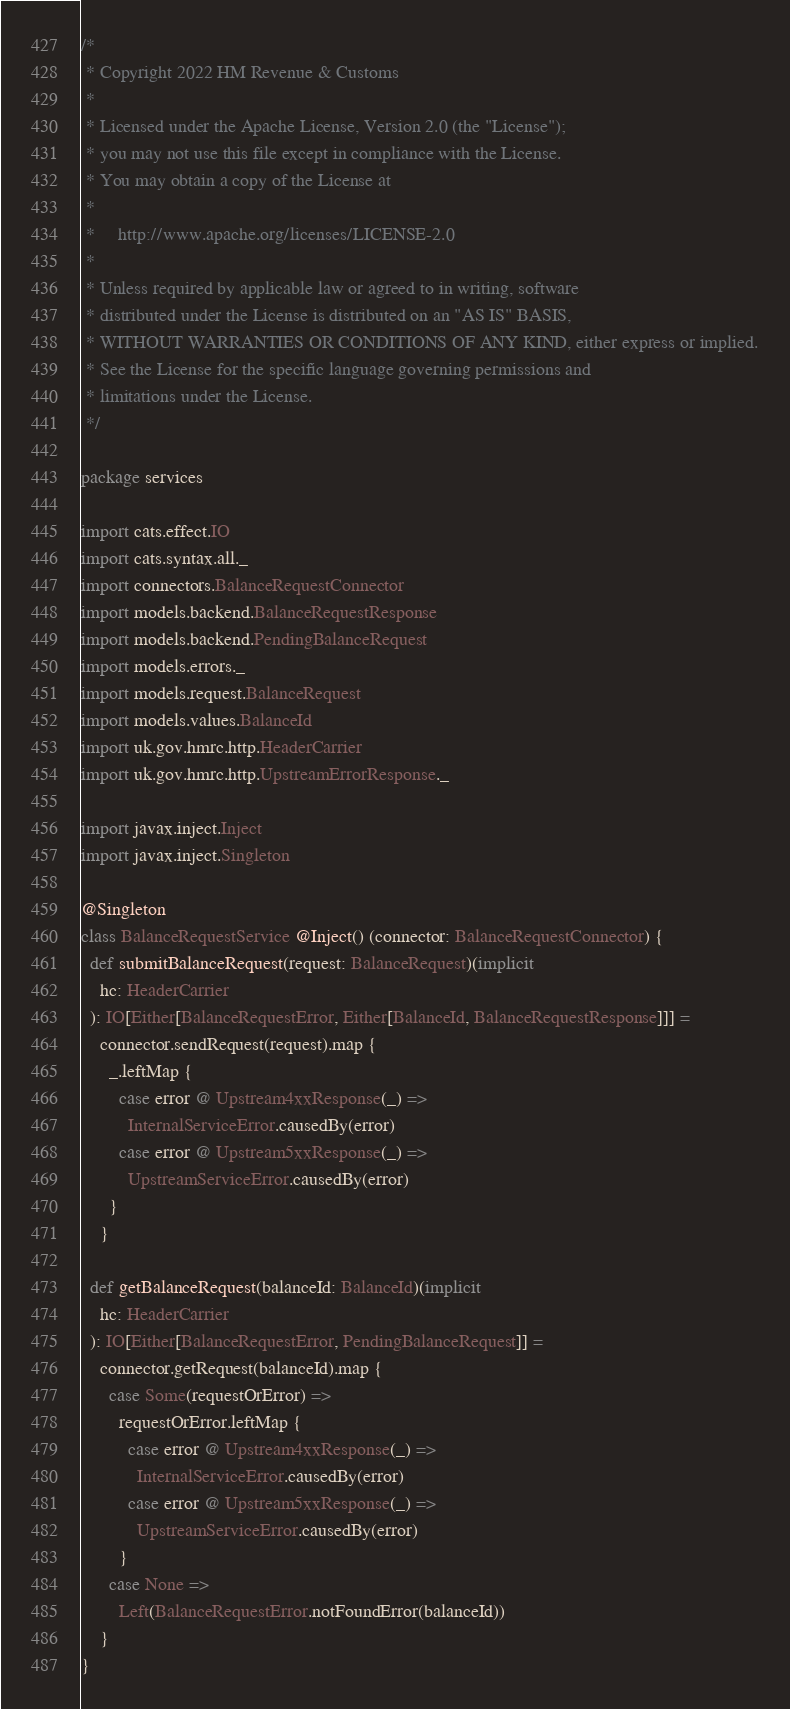Convert code to text. <code><loc_0><loc_0><loc_500><loc_500><_Scala_>/*
 * Copyright 2022 HM Revenue & Customs
 *
 * Licensed under the Apache License, Version 2.0 (the "License");
 * you may not use this file except in compliance with the License.
 * You may obtain a copy of the License at
 *
 *     http://www.apache.org/licenses/LICENSE-2.0
 *
 * Unless required by applicable law or agreed to in writing, software
 * distributed under the License is distributed on an "AS IS" BASIS,
 * WITHOUT WARRANTIES OR CONDITIONS OF ANY KIND, either express or implied.
 * See the License for the specific language governing permissions and
 * limitations under the License.
 */

package services

import cats.effect.IO
import cats.syntax.all._
import connectors.BalanceRequestConnector
import models.backend.BalanceRequestResponse
import models.backend.PendingBalanceRequest
import models.errors._
import models.request.BalanceRequest
import models.values.BalanceId
import uk.gov.hmrc.http.HeaderCarrier
import uk.gov.hmrc.http.UpstreamErrorResponse._

import javax.inject.Inject
import javax.inject.Singleton

@Singleton
class BalanceRequestService @Inject() (connector: BalanceRequestConnector) {
  def submitBalanceRequest(request: BalanceRequest)(implicit
    hc: HeaderCarrier
  ): IO[Either[BalanceRequestError, Either[BalanceId, BalanceRequestResponse]]] =
    connector.sendRequest(request).map {
      _.leftMap {
        case error @ Upstream4xxResponse(_) =>
          InternalServiceError.causedBy(error)
        case error @ Upstream5xxResponse(_) =>
          UpstreamServiceError.causedBy(error)
      }
    }

  def getBalanceRequest(balanceId: BalanceId)(implicit
    hc: HeaderCarrier
  ): IO[Either[BalanceRequestError, PendingBalanceRequest]] =
    connector.getRequest(balanceId).map {
      case Some(requestOrError) =>
        requestOrError.leftMap {
          case error @ Upstream4xxResponse(_) =>
            InternalServiceError.causedBy(error)
          case error @ Upstream5xxResponse(_) =>
            UpstreamServiceError.causedBy(error)
        }
      case None =>
        Left(BalanceRequestError.notFoundError(balanceId))
    }
}
</code> 